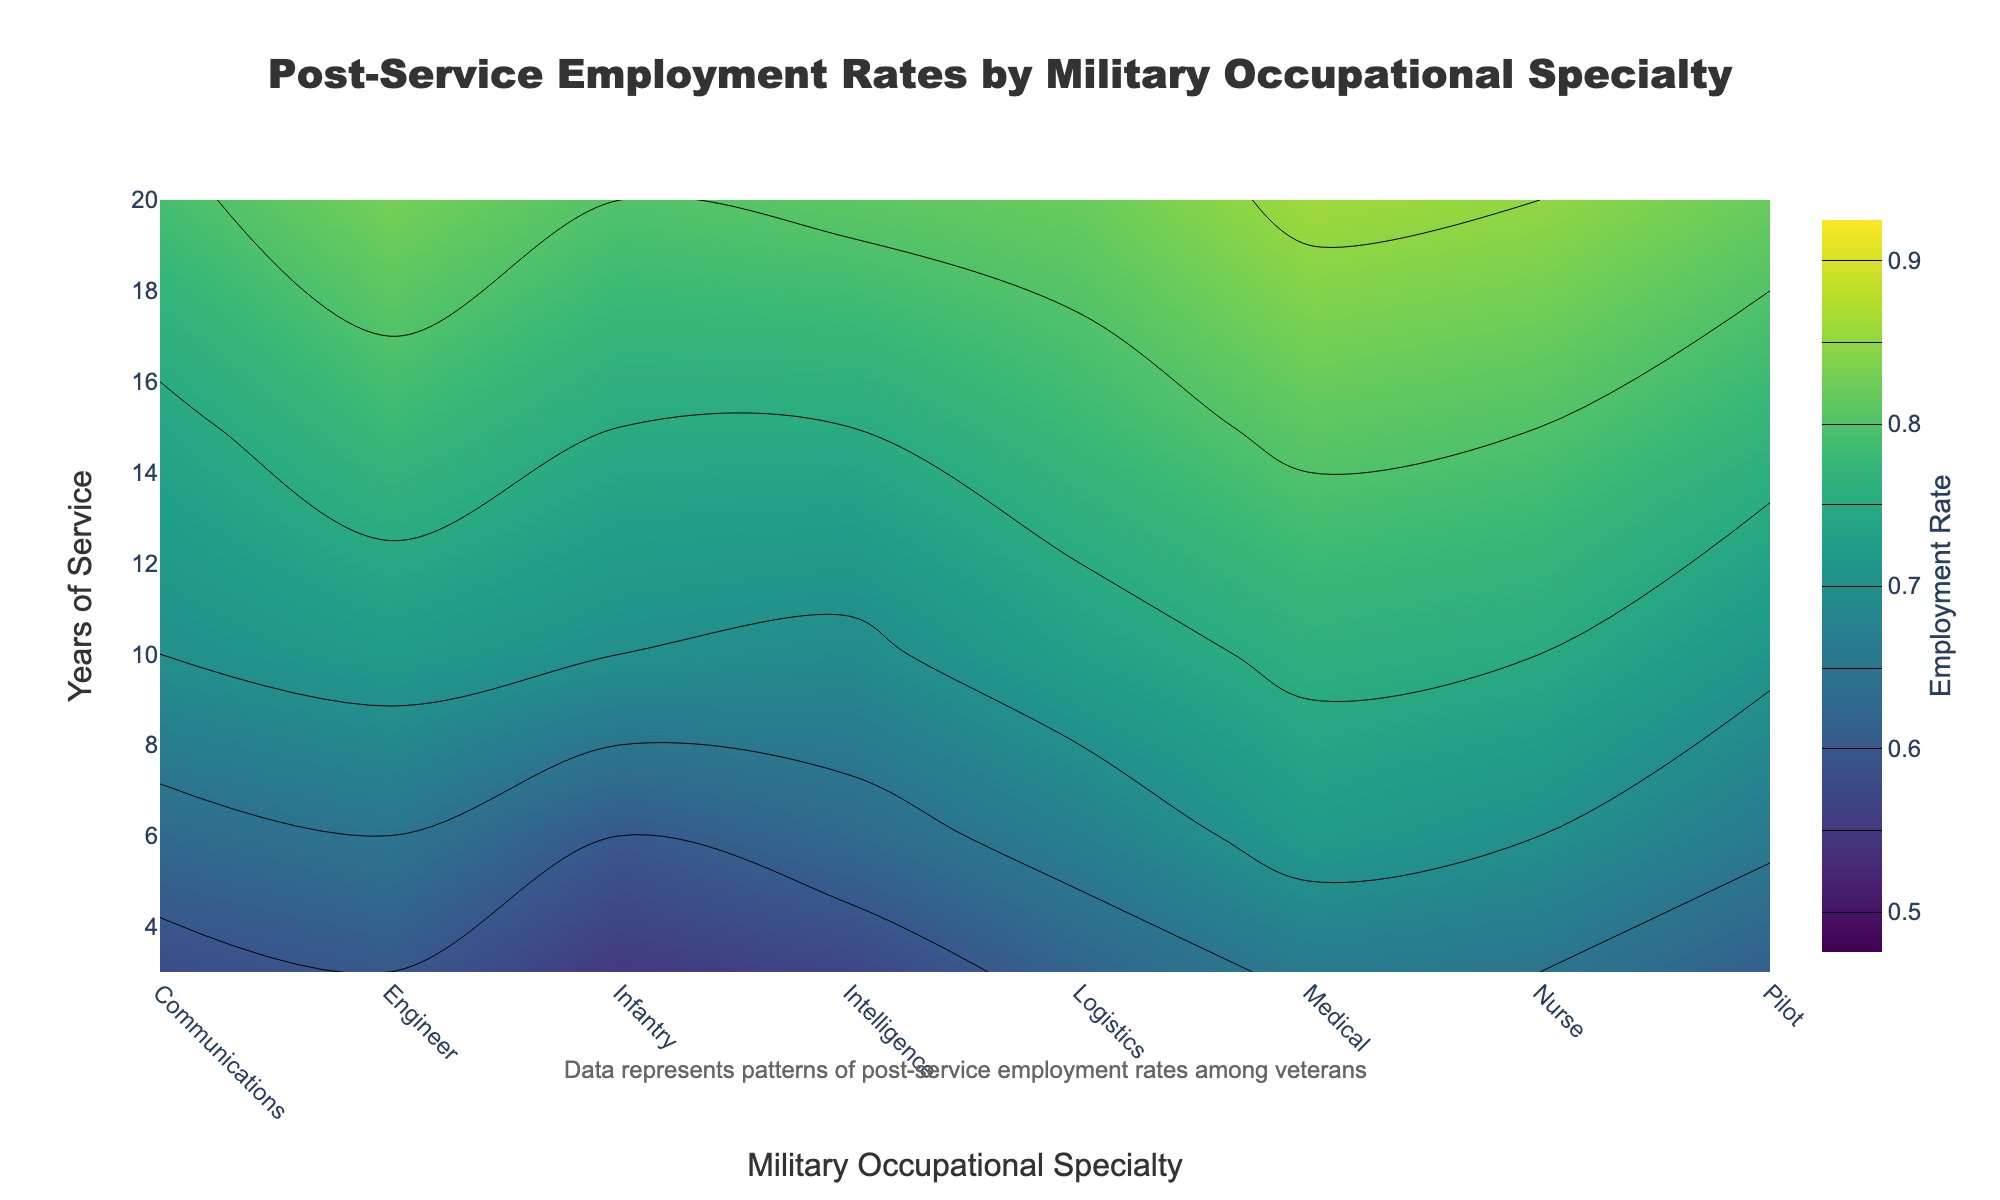What's the title of the figure? The title is usually found at the top of the figure, providing a brief description of the content. In this case, the title is "Post-Service Employment Rates by Military Occupational Specialty".
Answer: Post-Service Employment Rates by Military Occupational Specialty What does the y-axis represent? The label on the y-axis indicates what it represents. Here, it shows "Years of Service", which is the length of time veterans have served in the military.
Answer: Years of Service Which Military Occupational Specialty has the highest post-service employment rate at 10 years of service? In the contour plot, for the 10 years of service mark on the y-axis, we look for the highest contour line or the darkest shade of color, which corresponds to the Medical specialty.
Answer: Medical How does the employment rate change for Engineers as years of service increase? Follow the contour lines corresponding to Engineers on the x-axis from 3 to 20 years of service. The rate consistently increases from around 0.60 to about 0.83.
Answer: It increases consistently Compare the post-service employment rates of Nurses and Pilots at 6 years of service. Find the points for Nurses and Pilots on the x-axis and trace upward to the 6 years of service level. Nurses have a higher rate (approximately 0.70) compared to Pilots (around 0.66).
Answer: Nurses have higher rates For which occupation does the employment rate cross 0.80 between 10 and 15 years of service? By observing the contour lines, the Nurse occupation's rate crosses 0.80 between these years.
Answer: Nurses What is the employment rate for Logistics at 15 years of service? Locate the intersection of Logistics on the x-axis and 15 years of service on the y-axis, then refer to the contour gradient. It indicates approximately 0.78.
Answer: Approximately 0.78 Which Military Occupational Specialties reach an 0.85 post-service employment rate? By examining the contour levels, the only occupation that reaches an 0.85 rate is Medical at 20 years.
Answer: Medical Between Infantry and Intelligence, which has a higher employment rate at 20 years of service? Examine the contour levels at 20 years for both specialties. Infantry graduates to roughly 0.80, while Intelligence attains approximately 0.81.
Answer: Intelligence 